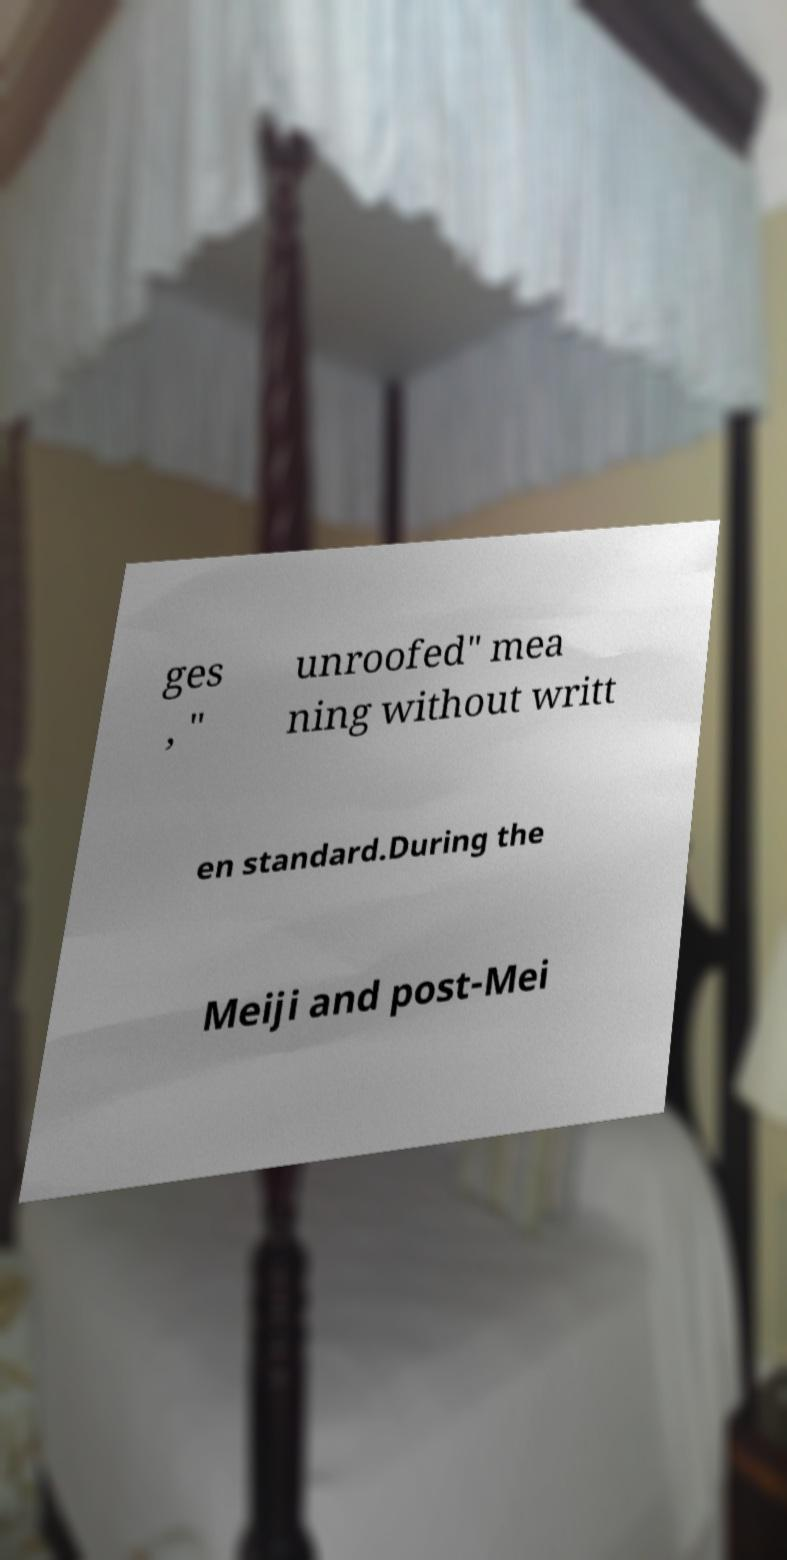Can you read and provide the text displayed in the image?This photo seems to have some interesting text. Can you extract and type it out for me? ges , " unroofed" mea ning without writt en standard.During the Meiji and post-Mei 